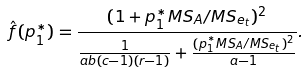<formula> <loc_0><loc_0><loc_500><loc_500>\hat { f } ( p _ { 1 } ^ { * } ) = \frac { ( 1 + p _ { 1 } ^ { * } M S _ { A } / M S _ { e _ { t } } ) ^ { 2 } } { \frac { 1 } { a b ( c - 1 ) ( r - 1 ) } + \frac { ( p _ { 1 } ^ { * } M S _ { A } / M S _ { e _ { t } } ) ^ { 2 } } { a - 1 } } .</formula> 